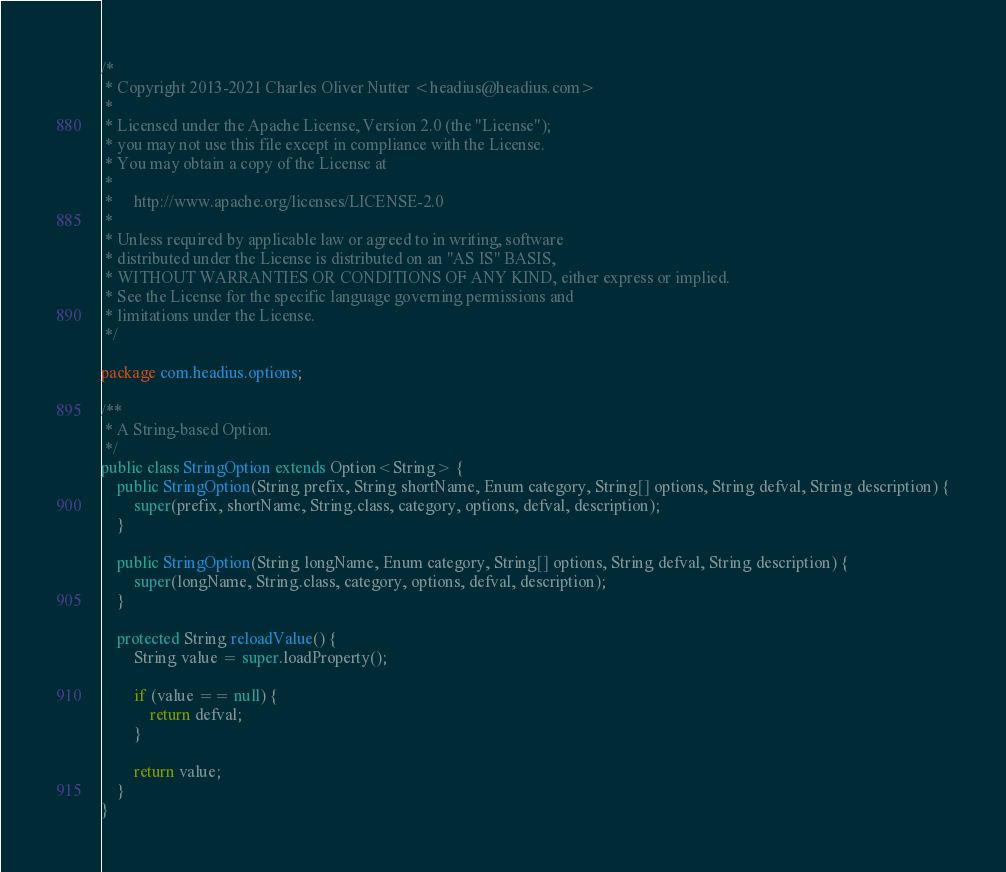<code> <loc_0><loc_0><loc_500><loc_500><_Java_>/*
 * Copyright 2013-2021 Charles Oliver Nutter <headius@headius.com>
 *
 * Licensed under the Apache License, Version 2.0 (the "License");
 * you may not use this file except in compliance with the License.
 * You may obtain a copy of the License at
 *
 *     http://www.apache.org/licenses/LICENSE-2.0
 *
 * Unless required by applicable law or agreed to in writing, software
 * distributed under the License is distributed on an "AS IS" BASIS,
 * WITHOUT WARRANTIES OR CONDITIONS OF ANY KIND, either express or implied.
 * See the License for the specific language governing permissions and
 * limitations under the License.
 */

package com.headius.options;

/**
 * A String-based Option.
 */
public class StringOption extends Option<String> {
    public StringOption(String prefix, String shortName, Enum category, String[] options, String defval, String description) {
        super(prefix, shortName, String.class, category, options, defval, description);
    }
    
    public StringOption(String longName, Enum category, String[] options, String defval, String description) {
        super(longName, String.class, category, options, defval, description);
    }

    protected String reloadValue() {
        String value = super.loadProperty();

        if (value == null) {
            return defval;
        }

        return value;
    }
}
</code> 